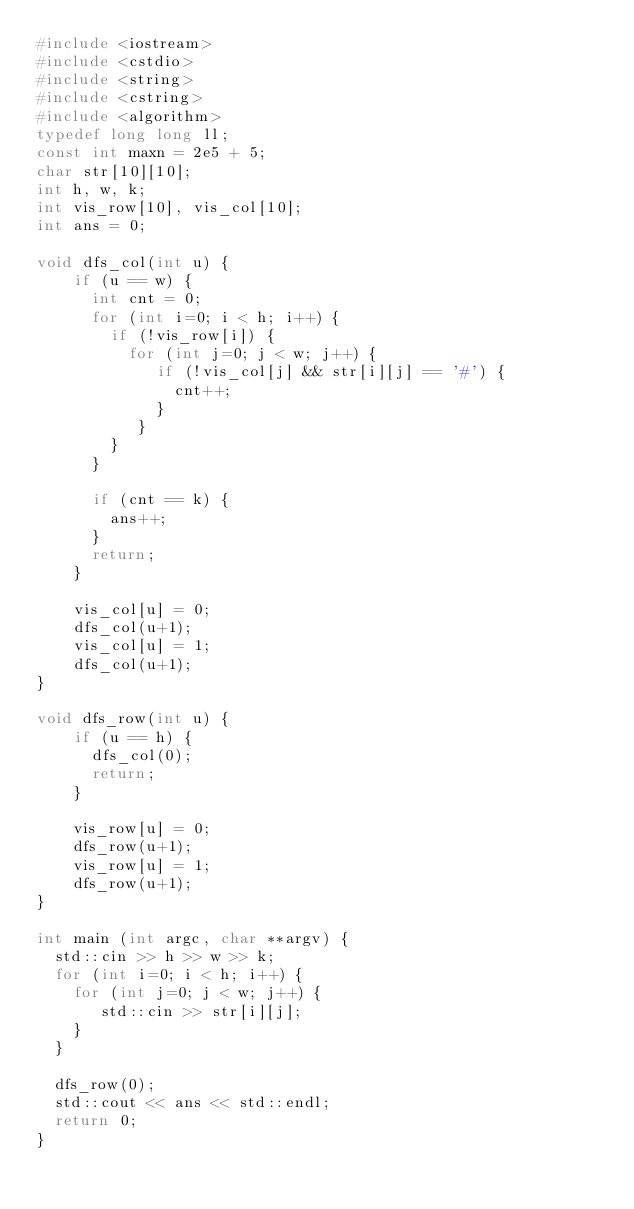<code> <loc_0><loc_0><loc_500><loc_500><_C++_>#include <iostream>
#include <cstdio>
#include <string>
#include <cstring>
#include <algorithm>
typedef long long ll;
const int maxn = 2e5 + 5;
char str[10][10];
int h, w, k;
int vis_row[10], vis_col[10];
int ans = 0;

void dfs_col(int u) {
    if (u == w) {
      int cnt = 0;
      for (int i=0; i < h; i++) {
        if (!vis_row[i]) {
          for (int j=0; j < w; j++) {
             if (!vis_col[j] && str[i][j] == '#') {
               cnt++;
             }
           }
        }
      }

      if (cnt == k) {
        ans++;
      }
      return;
    }

    vis_col[u] = 0;
    dfs_col(u+1);
    vis_col[u] = 1;
    dfs_col(u+1);
}

void dfs_row(int u) {
    if (u == h) {
      dfs_col(0);
      return;
    }

    vis_row[u] = 0;
    dfs_row(u+1);
    vis_row[u] = 1;
    dfs_row(u+1);
}

int main (int argc, char **argv) {
  std::cin >> h >> w >> k;
  for (int i=0; i < h; i++) {
    for (int j=0; j < w; j++) {
       std::cin >> str[i][j];
    }
  }

  dfs_row(0);
  std::cout << ans << std::endl;
  return 0;
}
</code> 